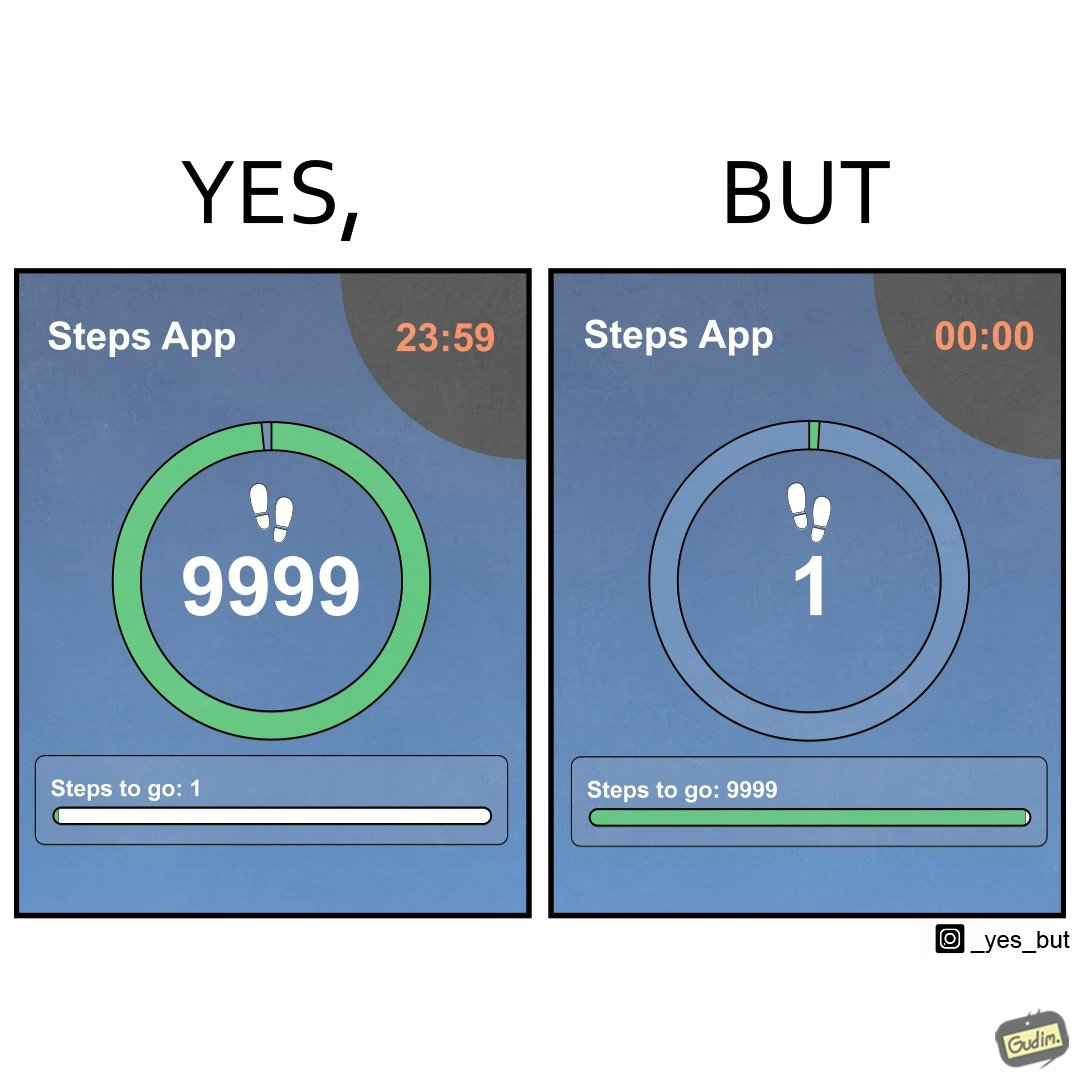Compare the left and right sides of this image. In the left part of the image: It is a step counting app showing that the user is only one step away from his daily target of 10000 steps In the right part of the image: It is a step counting app showing that the user is 9999 step away from his daily target of 10000 steps 